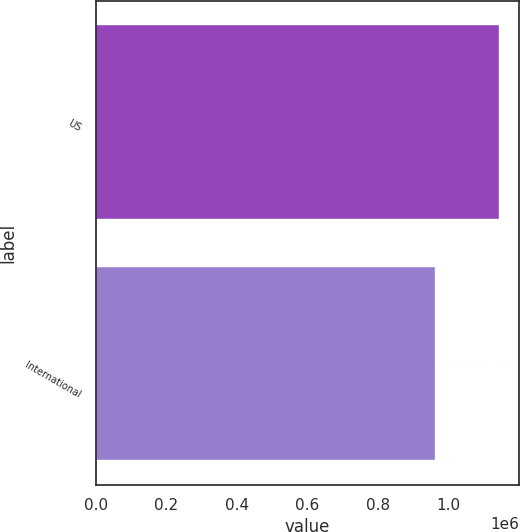<chart> <loc_0><loc_0><loc_500><loc_500><bar_chart><fcel>US<fcel>International<nl><fcel>1.141e+06<fcel>960000<nl></chart> 